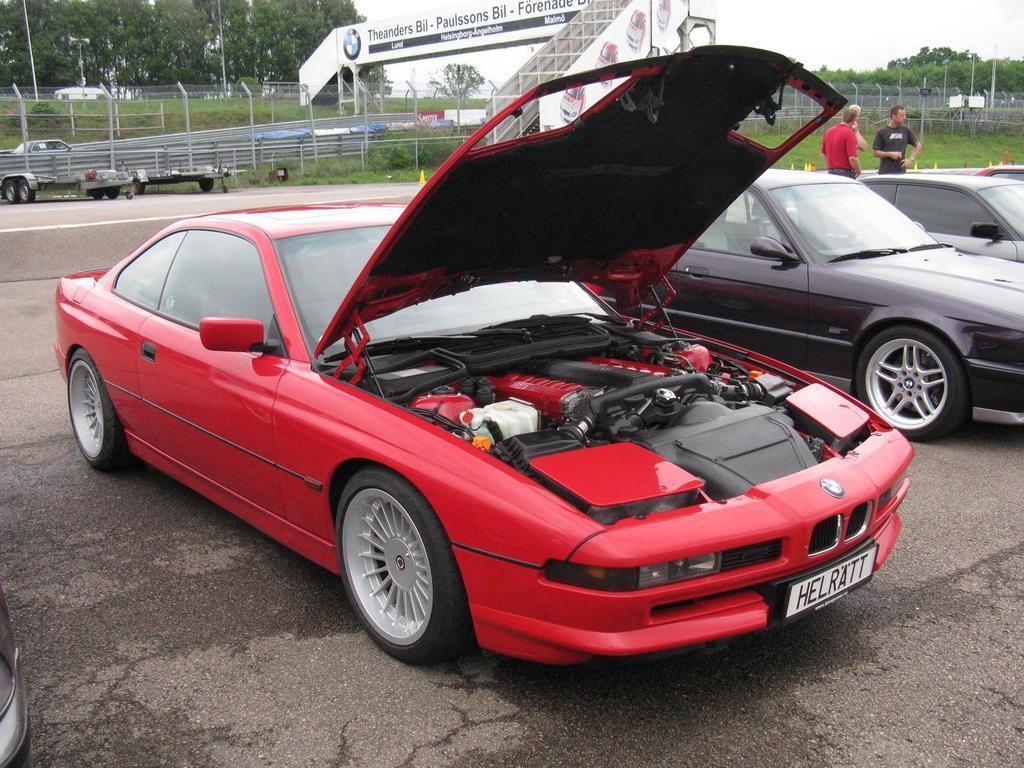Could you give a brief overview of what you see in this image? In the picture we can see a car parked on the path, the car is red in color and beside it, we can see some other cars are parked and behind it, we can see two people are standing, and behind them, we can see a road and grass surface and behind it we can see fencing and fly over the path and in the background we can see trees and sky. 